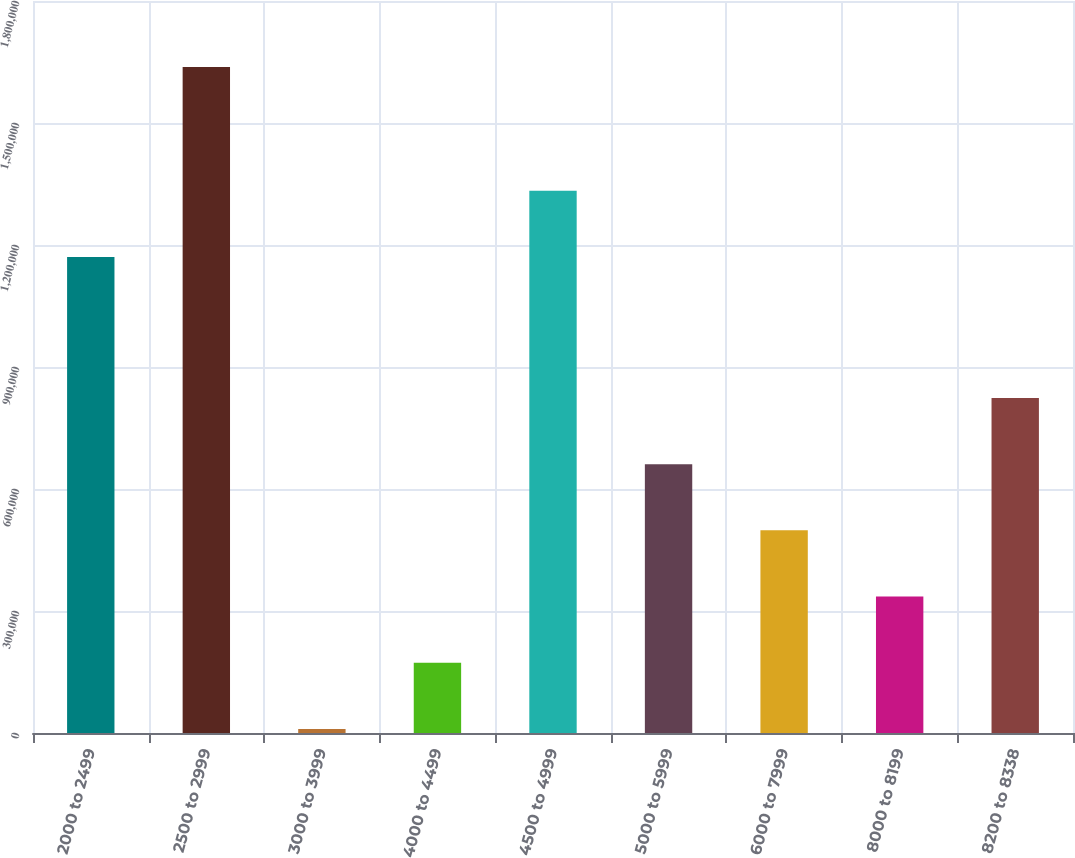Convert chart to OTSL. <chart><loc_0><loc_0><loc_500><loc_500><bar_chart><fcel>2000 to 2499<fcel>2500 to 2999<fcel>3000 to 3999<fcel>4000 to 4499<fcel>4500 to 4999<fcel>5000 to 5999<fcel>6000 to 7999<fcel>8000 to 8199<fcel>8200 to 8338<nl><fcel>1.17068e+06<fcel>1.63791e+06<fcel>10000<fcel>172791<fcel>1.33347e+06<fcel>661164<fcel>498373<fcel>335582<fcel>823956<nl></chart> 